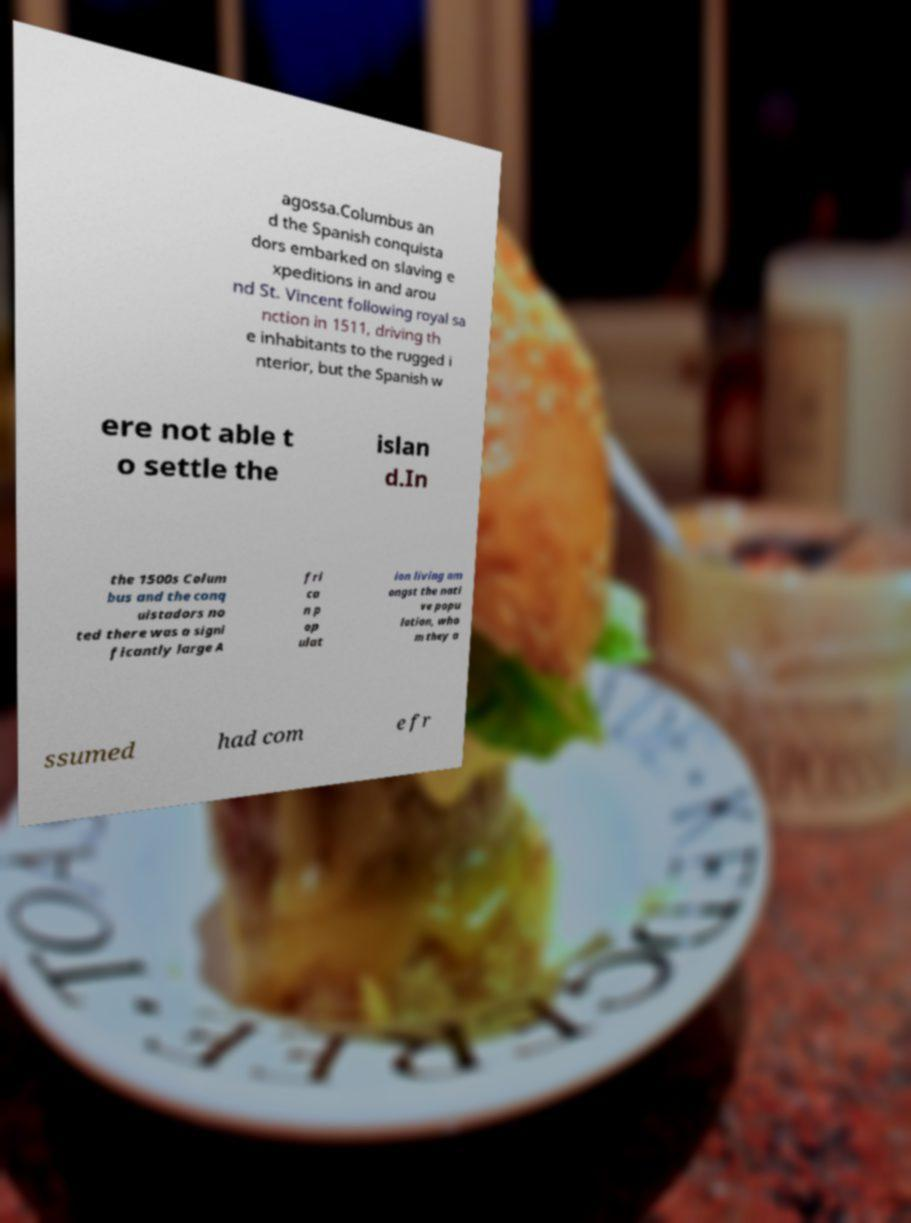Please identify and transcribe the text found in this image. agossa.Columbus an d the Spanish conquista dors embarked on slaving e xpeditions in and arou nd St. Vincent following royal sa nction in 1511, driving th e inhabitants to the rugged i nterior, but the Spanish w ere not able t o settle the islan d.In the 1500s Colum bus and the conq uistadors no ted there was a signi ficantly large A fri ca n p op ulat ion living am ongst the nati ve popu lation, who m they a ssumed had com e fr 